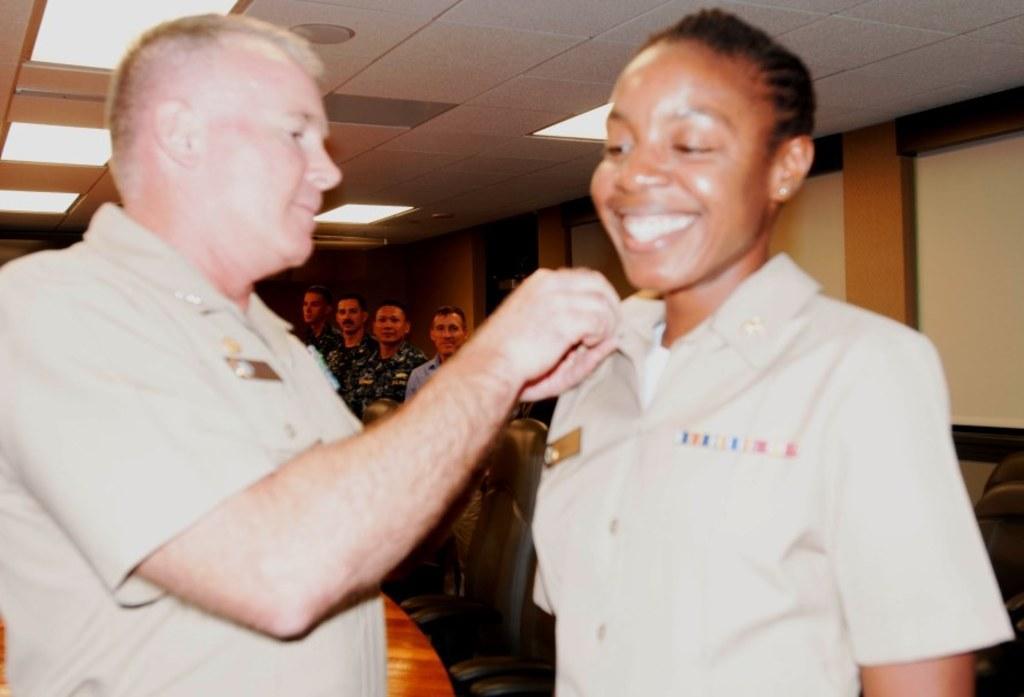Could you give a brief overview of what you see in this image? In this picture we can see some people are standing, there are some chairs in the middle, on the right side we can see projector screen, we can see the ceiling and lights at the top of the picture. 